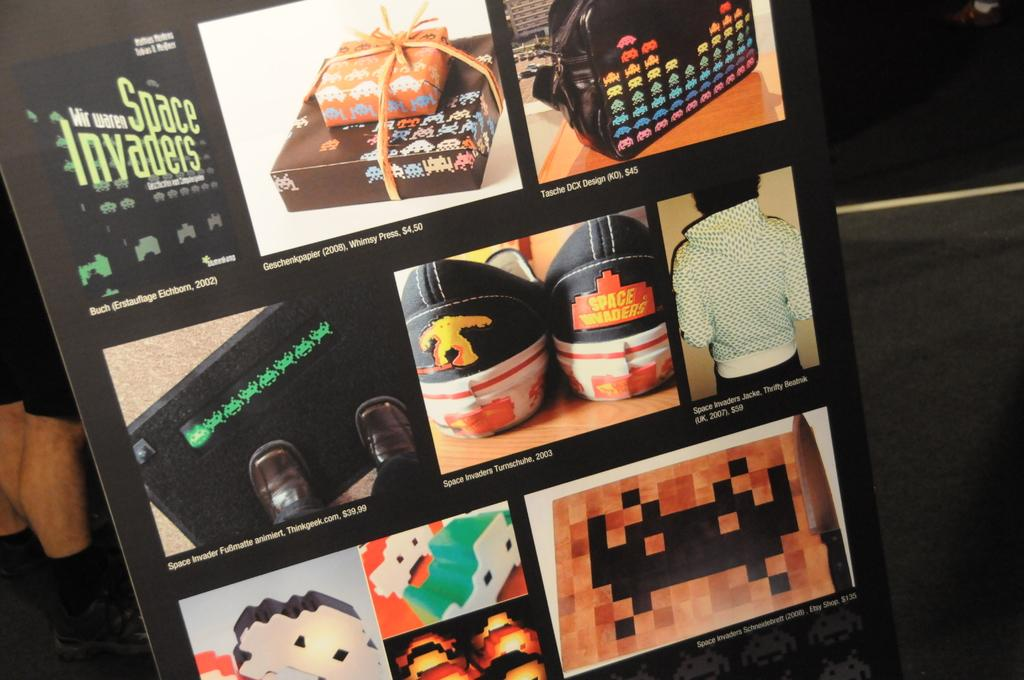Provide a one-sentence caption for the provided image. Collage of images with Space Invaders in the top left. 